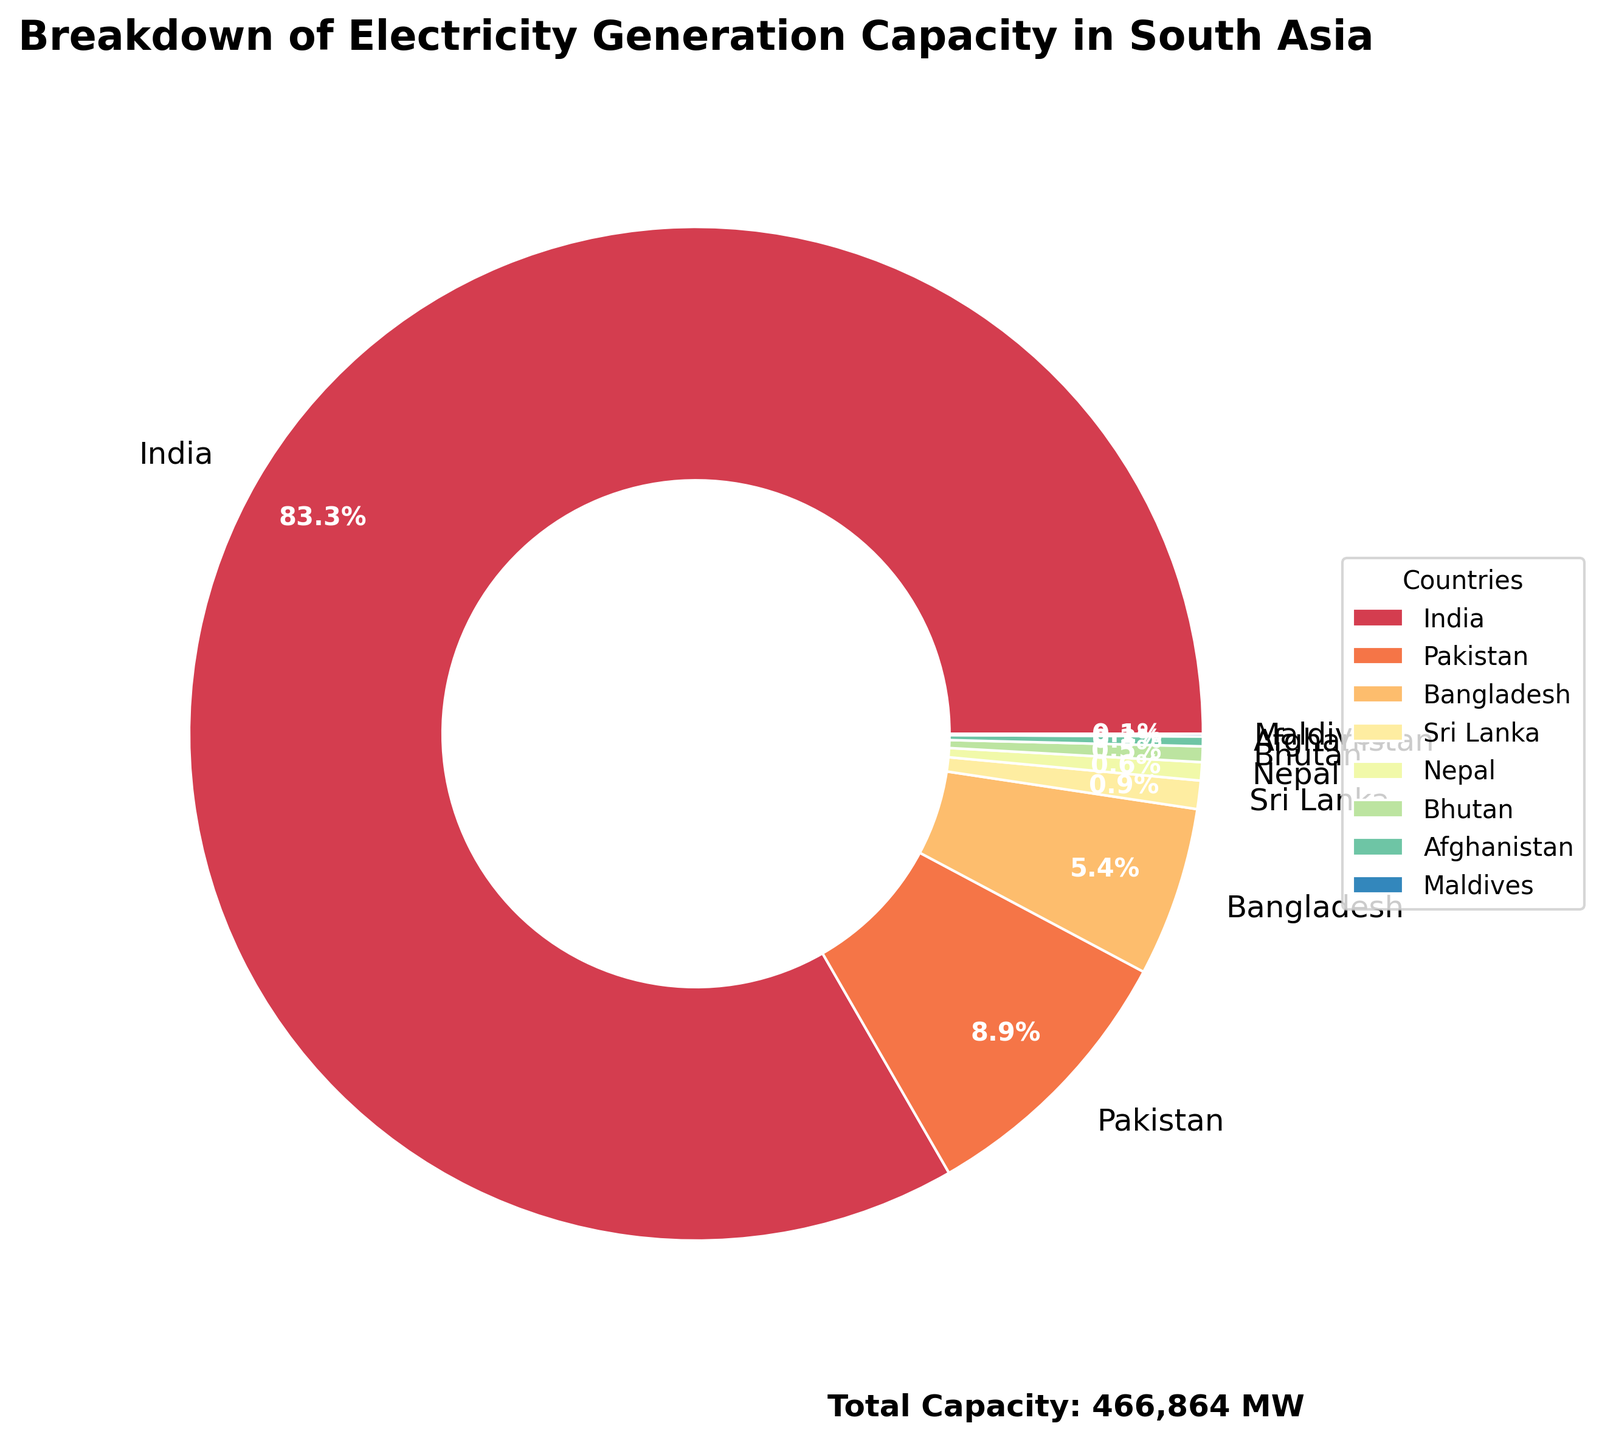Which country has the largest share of electricity generation capacity? India occupies the largest portion of the pie chart. The sector labeled "India" dominates the chart visually, indicating it has the most significant share among all listed countries.
Answer: India What is the combined percentage share of Bangladesh and Pakistan in electricity generation capacity? Bangladesh and Pakistan have respective shares of the pie chart. Visually adding their percentage slices, Pakistan's 8.3% added to Bangladesh's 5% gives a total of 13.3%.
Answer: 13.3% How does Sri Lanka’s electricity generation capacity compare to Nepal's? In the pie chart, Sri Lanka's section is slightly larger than Nepal's. While sizes are close, the exact percentage confirms that Sri Lanka’s share (1%) is larger compared to Nepal’s (0.6%).
Answer: Sri Lanka has more capacity What percentage of the total electricity generation capacity does India contribute? The pie chart shows India's segment. Visually, India's share is substantial, and its labeled percentage points out a dominant 78.2% of the total generation capacity.
Answer: 78.2% Which two countries have the smallest shares in electricity generation capacity and what are their combined percentages? The smallest sectors in the pie chart are labeled "Maldives" and "Afghanistan." Adding their percentages (0.1% + 0.3%), we get a combined share.
Answer: Maldives and Afghanistan, combined 0.4% How many countries have an electricity generation capacity share of less than 2%? From the pie chart, count the segments with shares less than 2%. Visually, Bhutan, Maldives, Afghanistan, Nepal, and Sri Lanka each have shares below 2%.
Answer: 5 countries What is the total electricity generation capacity for the three countries with the smallest shares? Identify the segments for Maldives, Afghanistan, and Bhutan, convert their percentages to the actual MW values by multiplying with the total capacity (493,864 MW), and sum them. Maldives: 402 MW, Afghanistan: 1450 MW, Bhutan: 2326 MW, so 402 + 1450 + 2326 = 4178 MW.
Answer: 4178 MW Which country’s share is closest to 5% of the total electricity generation capacity? The pie chart indicates Bangladesh having a share close to 5%. The exact labeled percentage for Bangladesh is displayed at 5%.
Answer: Bangladesh 